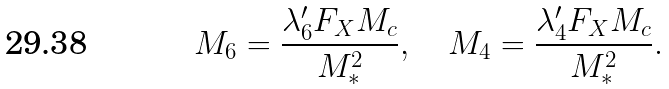<formula> <loc_0><loc_0><loc_500><loc_500>M _ { 6 } = \frac { \lambda _ { 6 } ^ { \prime } F _ { X } M _ { c } } { M ^ { 2 } _ { * } } , \quad M _ { 4 } = \frac { \lambda _ { 4 } ^ { \prime } F _ { X } M _ { c } } { M ^ { 2 } _ { * } } .</formula> 